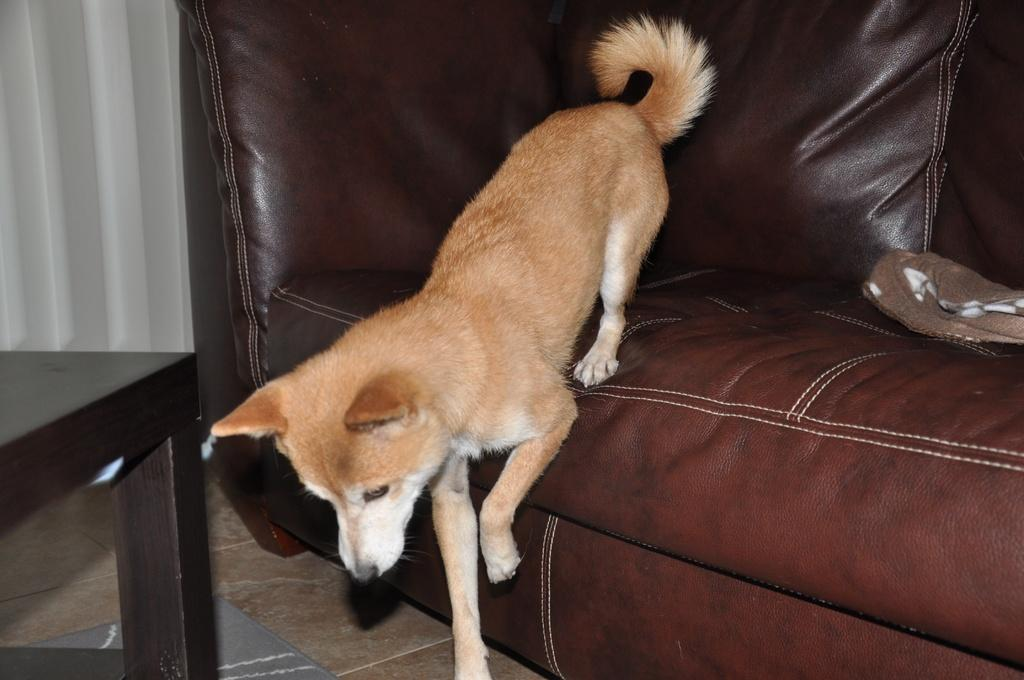What animal can be seen in the image? There is a dog in the image. What is the dog doing in the image? The dog is getting down from a sofa. What furniture is present in the image? There is a table in the image. What type of window treatment is visible in the image? There are curtains in the image. What color of paint is being used by the dog in the image? There is no paint or painting activity involving the dog in the image. 